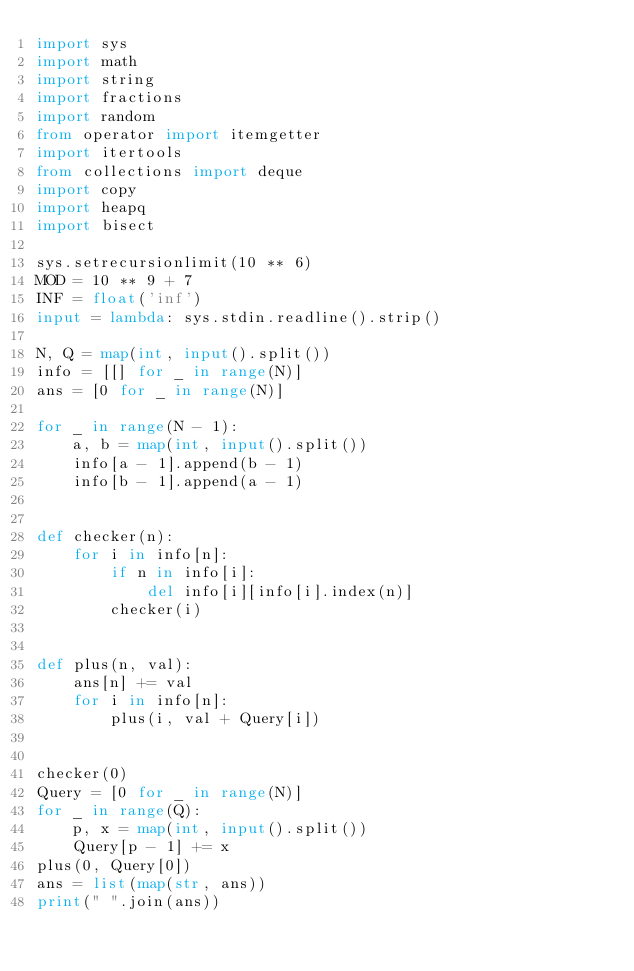<code> <loc_0><loc_0><loc_500><loc_500><_Python_>import sys
import math
import string
import fractions
import random
from operator import itemgetter
import itertools
from collections import deque
import copy
import heapq
import bisect

sys.setrecursionlimit(10 ** 6)
MOD = 10 ** 9 + 7
INF = float('inf')
input = lambda: sys.stdin.readline().strip()

N, Q = map(int, input().split())
info = [[] for _ in range(N)]
ans = [0 for _ in range(N)]

for _ in range(N - 1):
    a, b = map(int, input().split())
    info[a - 1].append(b - 1)
    info[b - 1].append(a - 1)


def checker(n):
    for i in info[n]:
        if n in info[i]:
            del info[i][info[i].index(n)]
        checker(i)


def plus(n, val):
    ans[n] += val
    for i in info[n]:
        plus(i, val + Query[i])


checker(0)
Query = [0 for _ in range(N)]
for _ in range(Q):
    p, x = map(int, input().split())
    Query[p - 1] += x
plus(0, Query[0])
ans = list(map(str, ans))
print(" ".join(ans))
</code> 